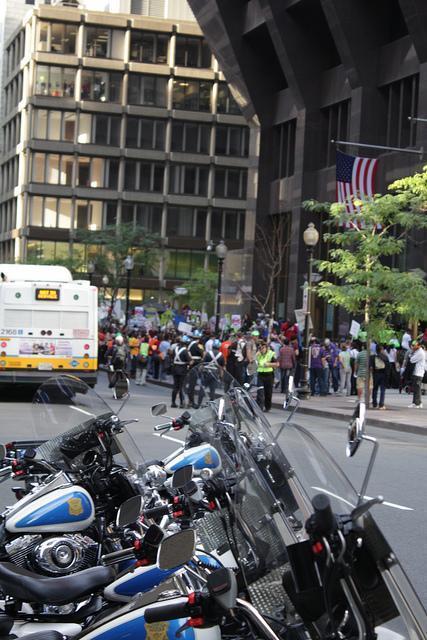How many lanes are on this highway?
Give a very brief answer. 2. How many motorcycles are there?
Give a very brief answer. 3. How many motorcycles can be seen?
Give a very brief answer. 3. How many toilets have a colored seat?
Give a very brief answer. 0. 